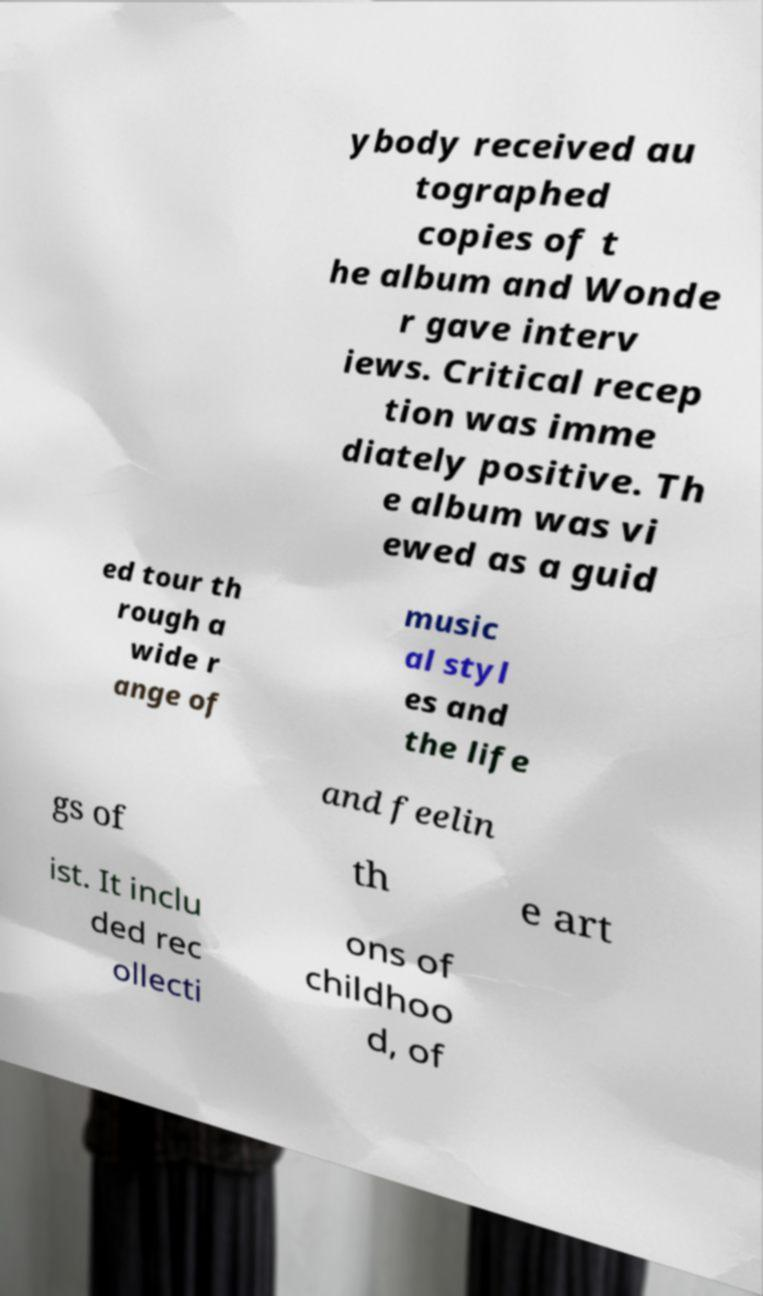I need the written content from this picture converted into text. Can you do that? ybody received au tographed copies of t he album and Wonde r gave interv iews. Critical recep tion was imme diately positive. Th e album was vi ewed as a guid ed tour th rough a wide r ange of music al styl es and the life and feelin gs of th e art ist. It inclu ded rec ollecti ons of childhoo d, of 